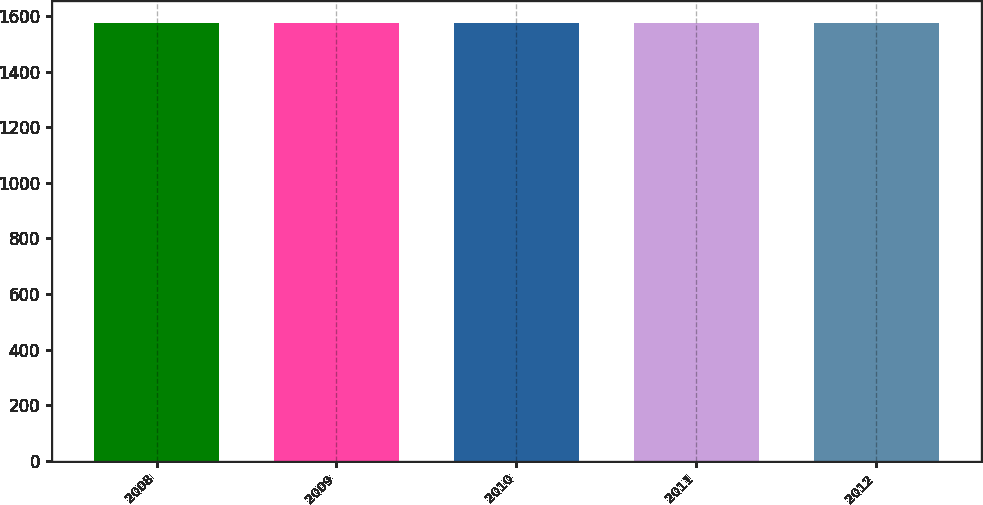<chart> <loc_0><loc_0><loc_500><loc_500><bar_chart><fcel>2008<fcel>2009<fcel>2010<fcel>2011<fcel>2012<nl><fcel>1577<fcel>1577.1<fcel>1577.2<fcel>1577.3<fcel>1577.4<nl></chart> 